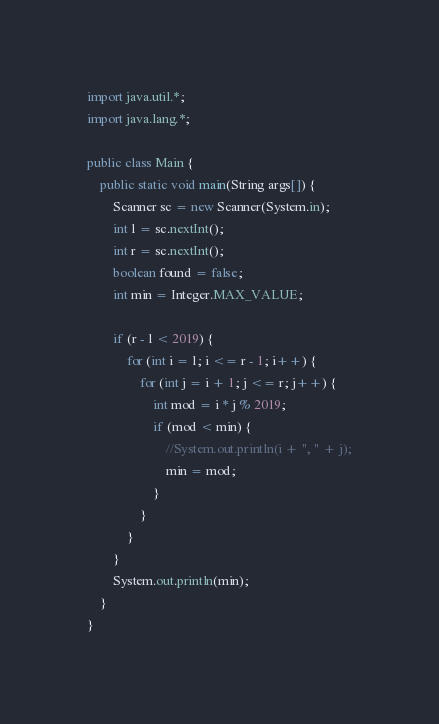<code> <loc_0><loc_0><loc_500><loc_500><_Java_>import java.util.*;
import java.lang.*;

public class Main {
    public static void main(String args[]) {
        Scanner sc = new Scanner(System.in);
        int l = sc.nextInt();
        int r = sc.nextInt();
        boolean found = false;
        int min = Integer.MAX_VALUE;
        
        if (r - l < 2019) {
            for (int i = l; i <= r - 1; i++) {
                for (int j = i + 1; j <= r; j++) {
                    int mod = i * j % 2019;
                    if (mod < min) {
                        //System.out.println(i + ", " + j);
                        min = mod;
                    }
                }
            }
        }
        System.out.println(min);
    }
}
</code> 